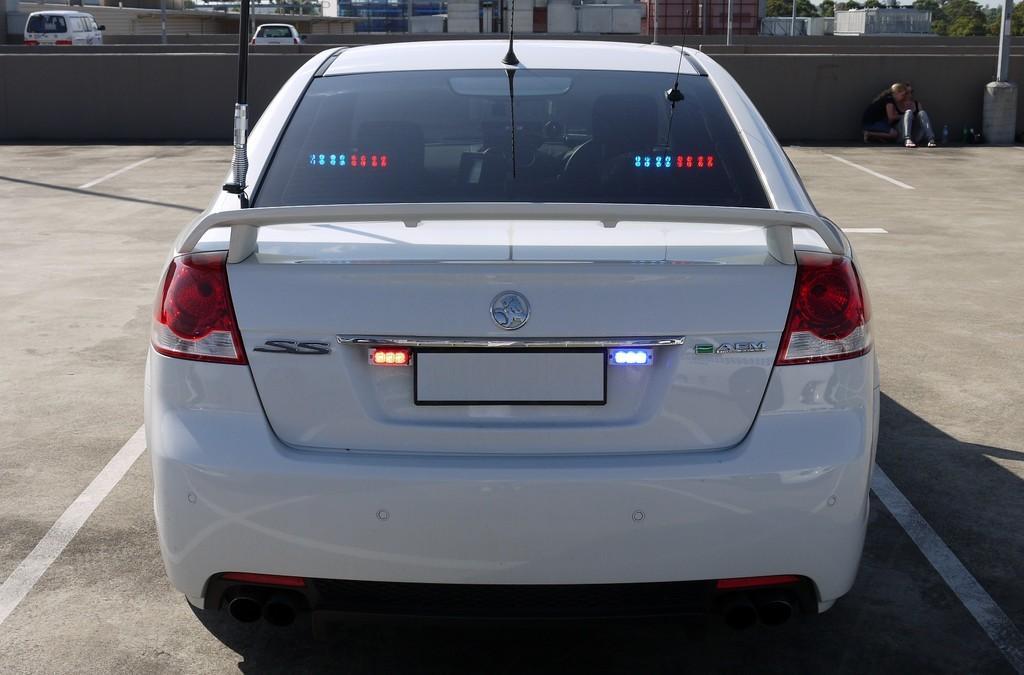Describe this image in one or two sentences. In this picture we can see a vehicle, people on the ground and in the background we can see a wall, vehicles, buildings, trees, poles and some objects. 